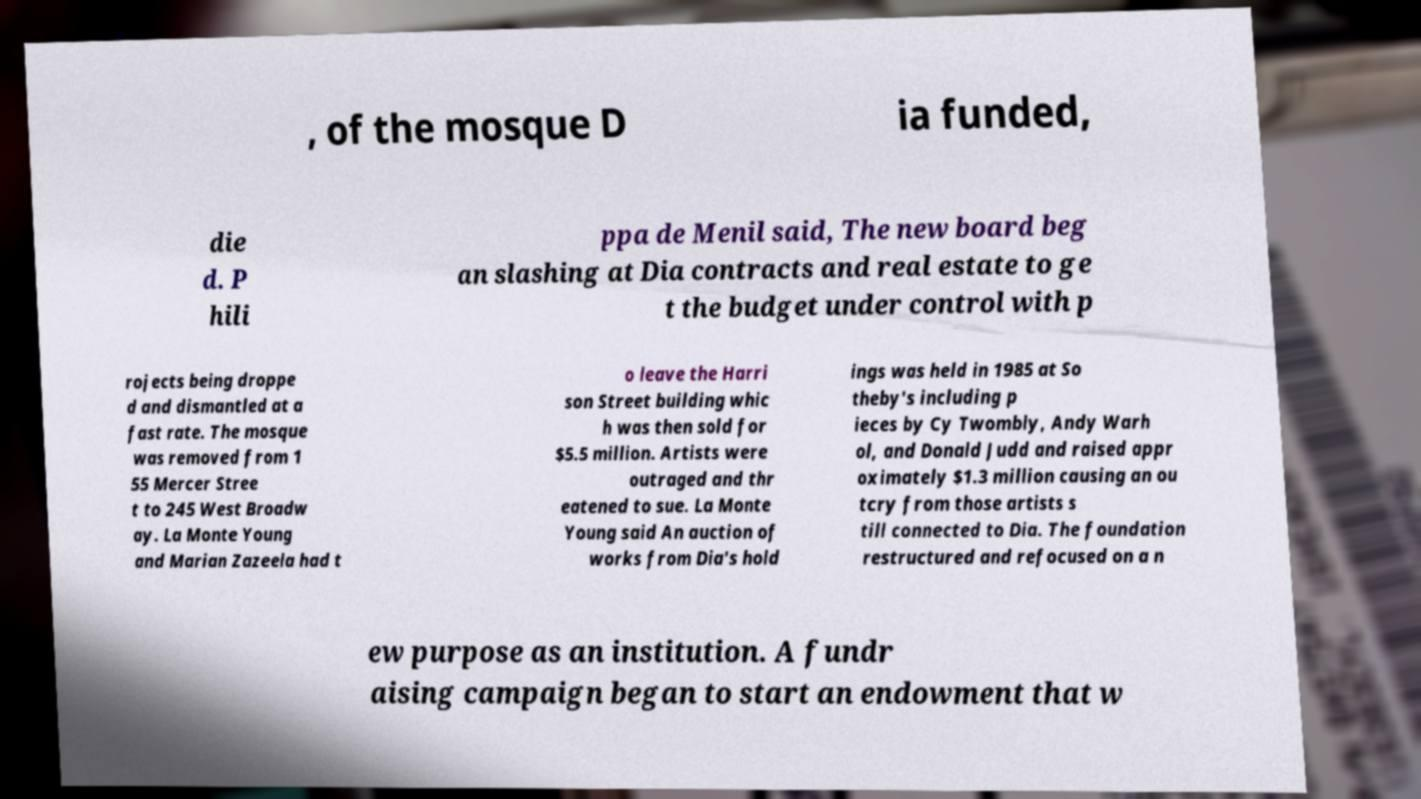What messages or text are displayed in this image? I need them in a readable, typed format. , of the mosque D ia funded, die d. P hili ppa de Menil said, The new board beg an slashing at Dia contracts and real estate to ge t the budget under control with p rojects being droppe d and dismantled at a fast rate. The mosque was removed from 1 55 Mercer Stree t to 245 West Broadw ay. La Monte Young and Marian Zazeela had t o leave the Harri son Street building whic h was then sold for $5.5 million. Artists were outraged and thr eatened to sue. La Monte Young said An auction of works from Dia's hold ings was held in 1985 at So theby's including p ieces by Cy Twombly, Andy Warh ol, and Donald Judd and raised appr oximately $1.3 million causing an ou tcry from those artists s till connected to Dia. The foundation restructured and refocused on a n ew purpose as an institution. A fundr aising campaign began to start an endowment that w 